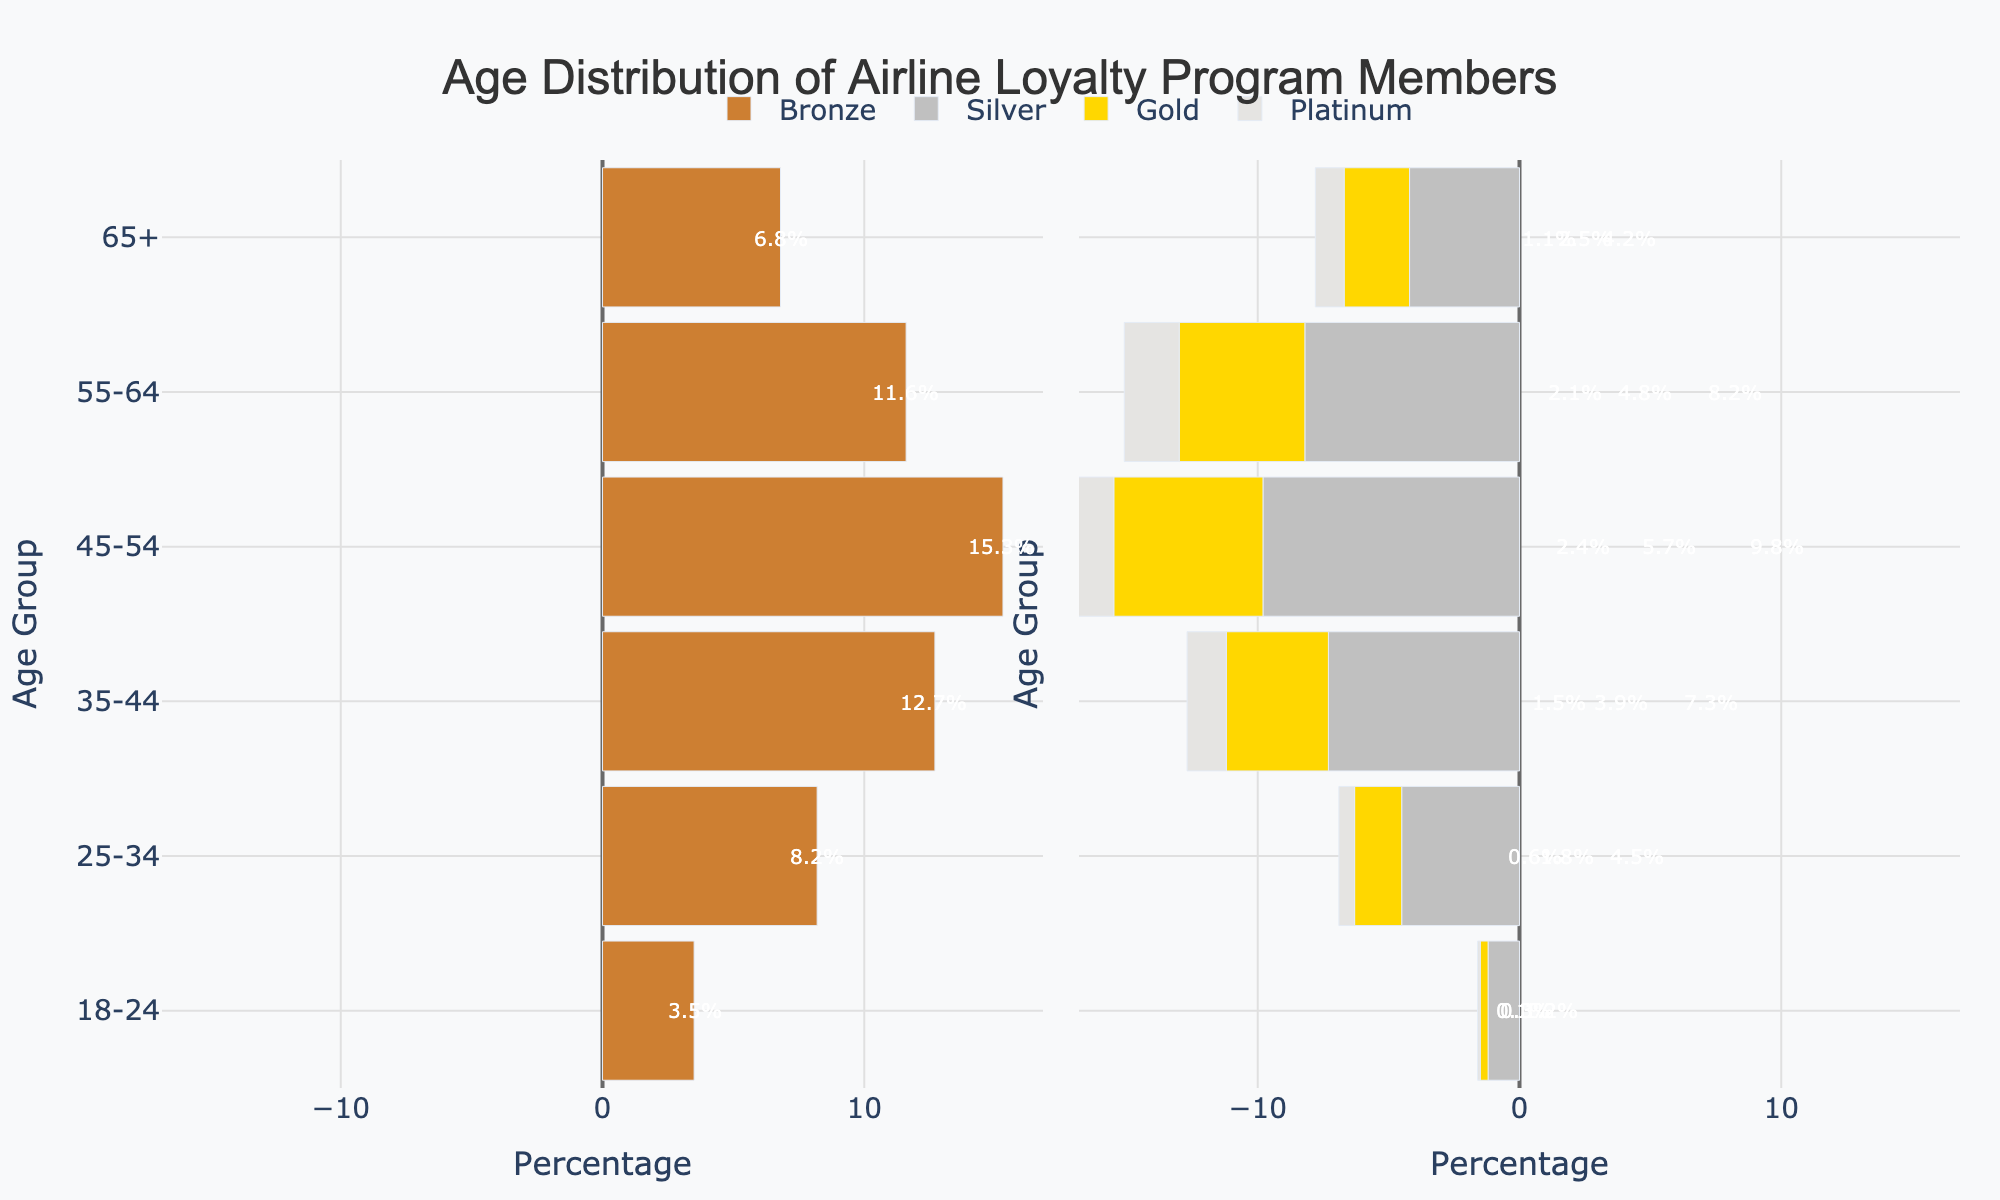 Which age group has the highest overall percentage of loyalty program members (across all tiers)?
Answer: Summing the percentages per age group: 
- 18-24: 3.5 + 1.2 + 0.3 + 0.1 = 5.1%
- 25-34: 8.2 + 4.5 + 1.8 + 0.6 = 15.1%
- 35-44: 12.7 + 7.3 + 3.9 + 1.5 = 25.4%
- 45-54: 15.3 + 9.8 + 5.7 + 2.4 = 33.2%
- 55-64: 11.6 + 8.2 + 4.8 + 2.1 = 26.7%
- 65+: 6.8 + 4.2 + 2.5 + 1.1 = 14.6% 